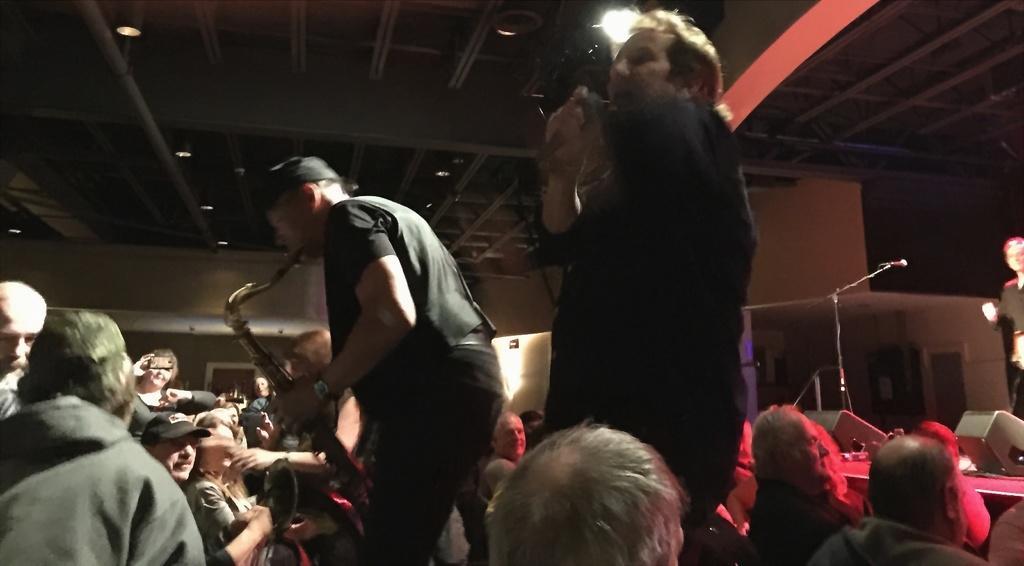Please provide a concise description of this image. In this image, we can see persons wearing clothes. There is a person in the middle of the image playing a musical instruments. There is a mic on the right side of the image. There are objects in the bottom right side of the image. There are lights at the top of the image. 